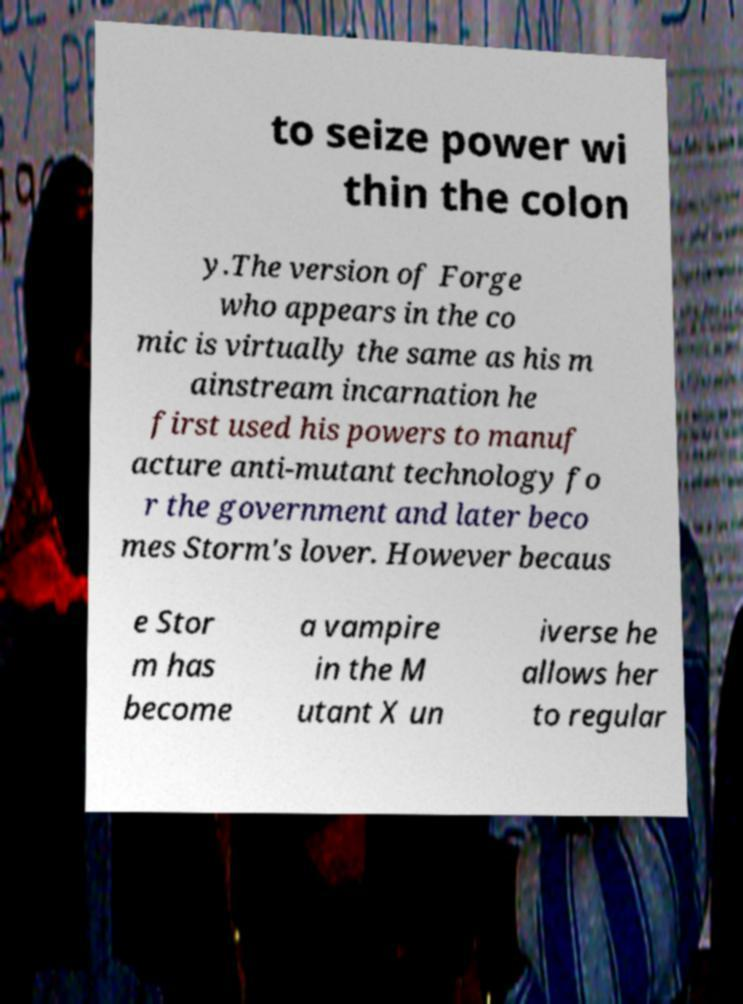Please identify and transcribe the text found in this image. to seize power wi thin the colon y.The version of Forge who appears in the co mic is virtually the same as his m ainstream incarnation he first used his powers to manuf acture anti-mutant technology fo r the government and later beco mes Storm's lover. However becaus e Stor m has become a vampire in the M utant X un iverse he allows her to regular 